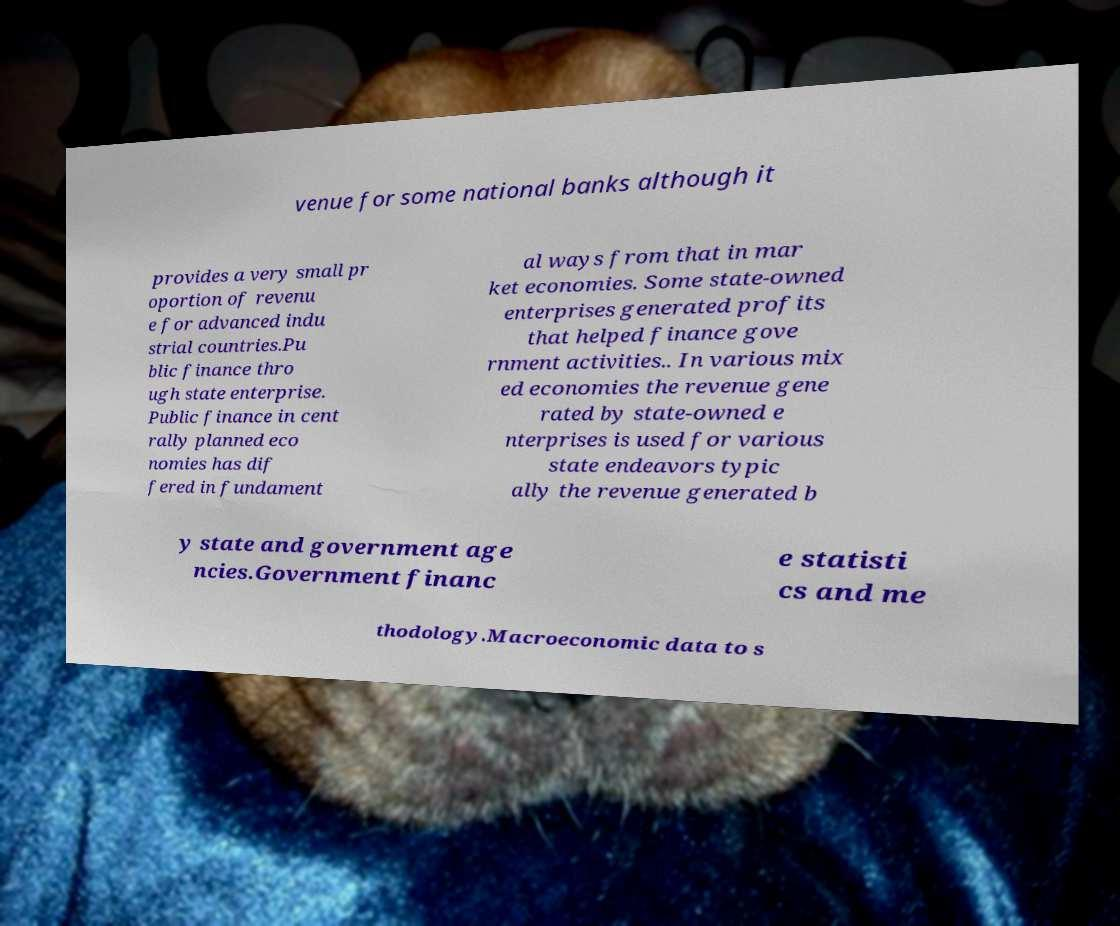Please identify and transcribe the text found in this image. venue for some national banks although it provides a very small pr oportion of revenu e for advanced indu strial countries.Pu blic finance thro ugh state enterprise. Public finance in cent rally planned eco nomies has dif fered in fundament al ways from that in mar ket economies. Some state-owned enterprises generated profits that helped finance gove rnment activities.. In various mix ed economies the revenue gene rated by state-owned e nterprises is used for various state endeavors typic ally the revenue generated b y state and government age ncies.Government financ e statisti cs and me thodology.Macroeconomic data to s 